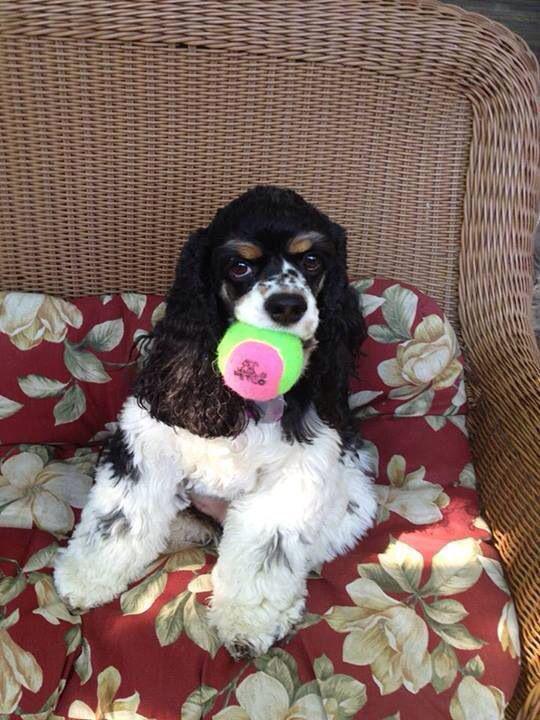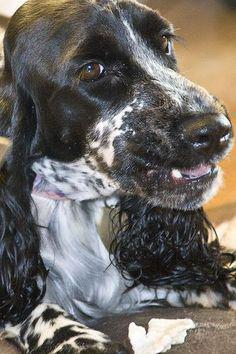The first image is the image on the left, the second image is the image on the right. Assess this claim about the two images: "A litter of puppies is being fed by their mother.". Correct or not? Answer yes or no. No. The first image is the image on the left, the second image is the image on the right. Considering the images on both sides, is "The right image contains no more than one dog." valid? Answer yes or no. Yes. 